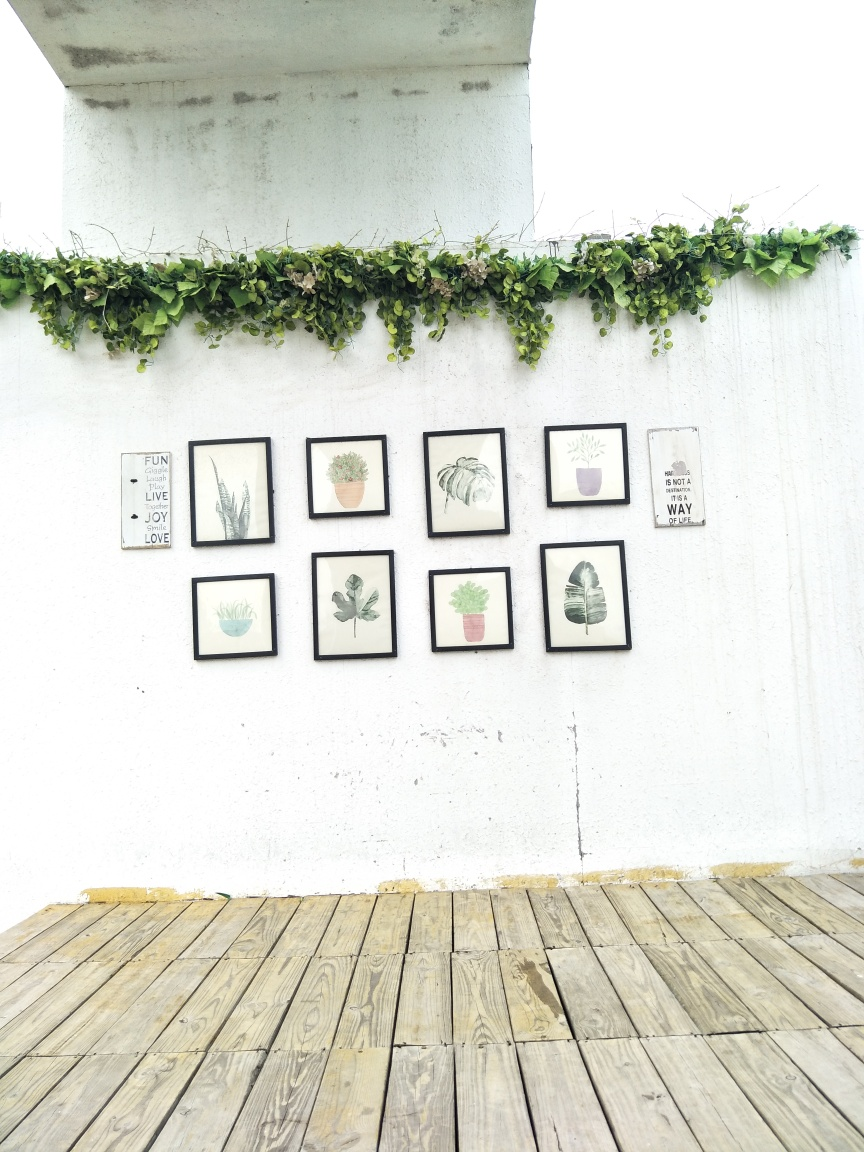Would the space benefit from additional colors, or is the current palette ideal? The current palette, with its earthy tones and hints of green, presents a minimalistic and coherent theme. This simplicity is ideal for promoting a restful and focused atmosphere. However, if one wanted to inject more energy or contrast into the space, small, thoughtful additions of complementary colors like soft blues or gentle yellows through accessories could enhance the existing decor without overwhelming it. The key is to introduce new colors which align with the overall peaceful and natural vibe of the setting. 